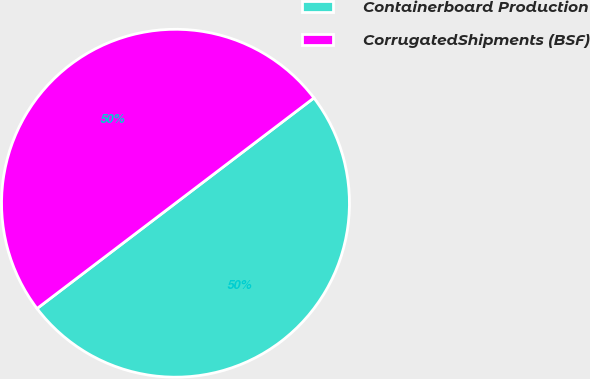Convert chart to OTSL. <chart><loc_0><loc_0><loc_500><loc_500><pie_chart><fcel>Containerboard Production<fcel>CorrugatedShipments (BSF)<nl><fcel>50.0%<fcel>50.0%<nl></chart> 